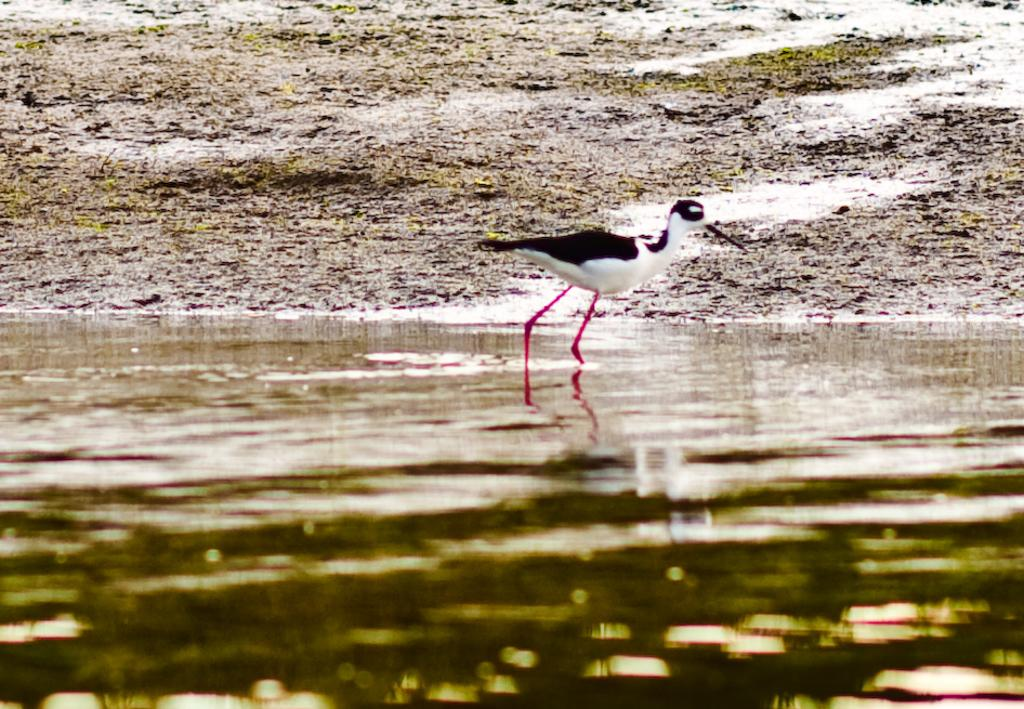What is on the water in the image? There is a stilt on the water. Can you describe the surrounding environment? There is land visible at the back. What type of cat is sitting on the stilt in the image? There is no cat present in the image; it features a stilt on the water and land visible at the back. 